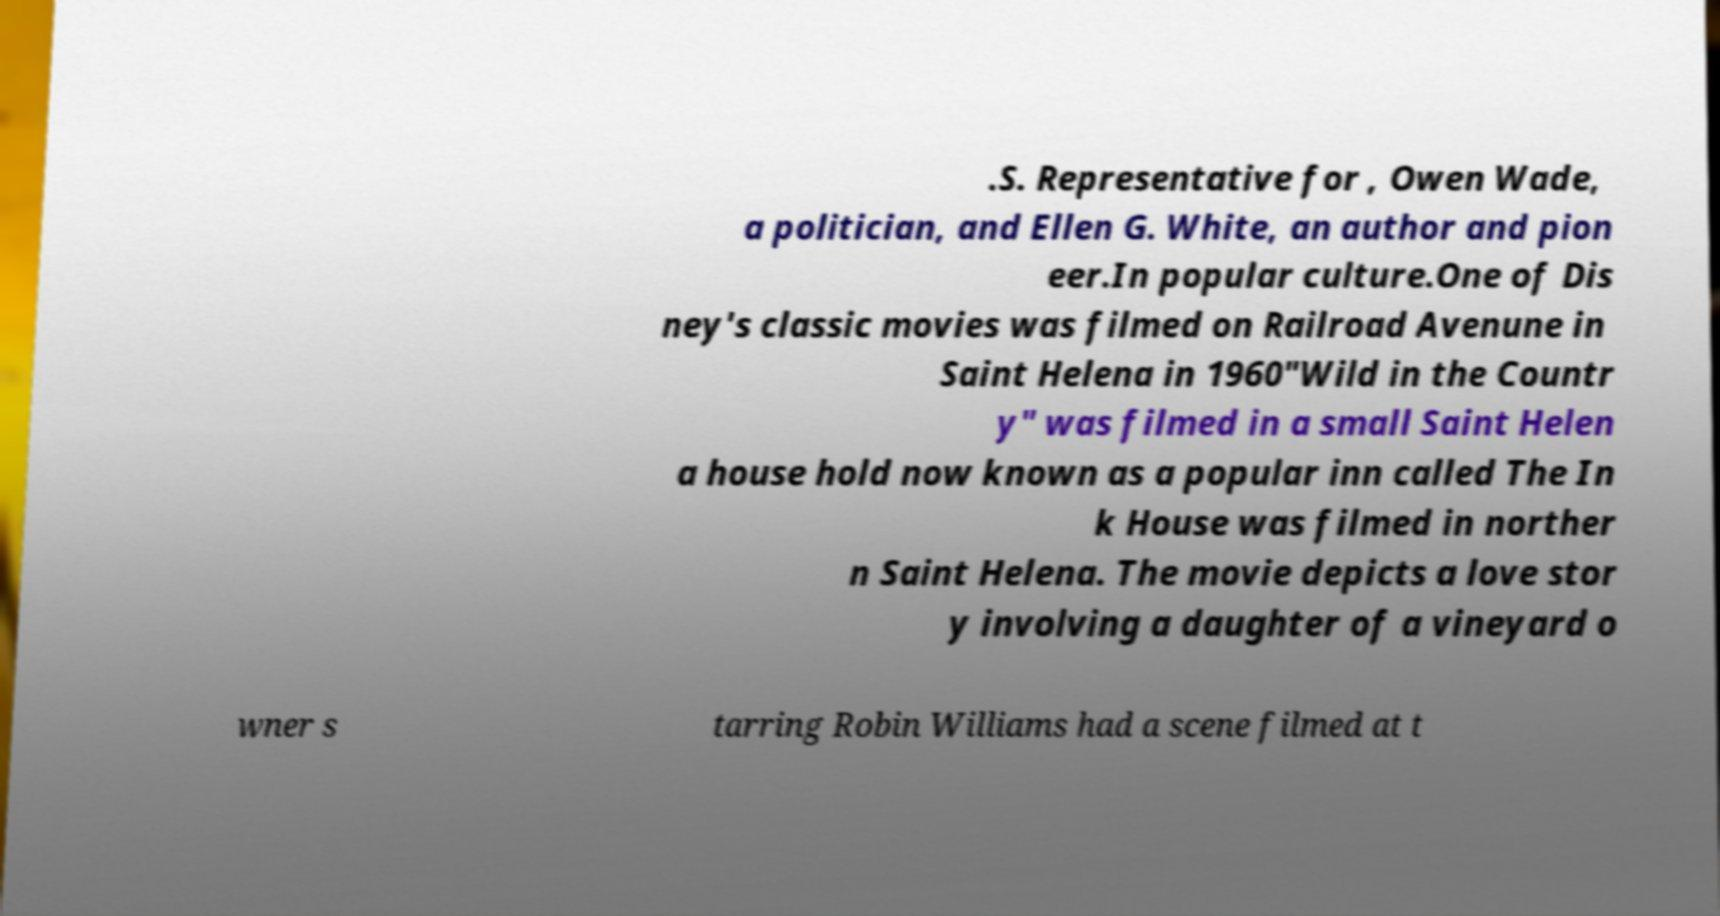Could you assist in decoding the text presented in this image and type it out clearly? .S. Representative for , Owen Wade, a politician, and Ellen G. White, an author and pion eer.In popular culture.One of Dis ney's classic movies was filmed on Railroad Avenune in Saint Helena in 1960"Wild in the Countr y" was filmed in a small Saint Helen a house hold now known as a popular inn called The In k House was filmed in norther n Saint Helena. The movie depicts a love stor y involving a daughter of a vineyard o wner s tarring Robin Williams had a scene filmed at t 